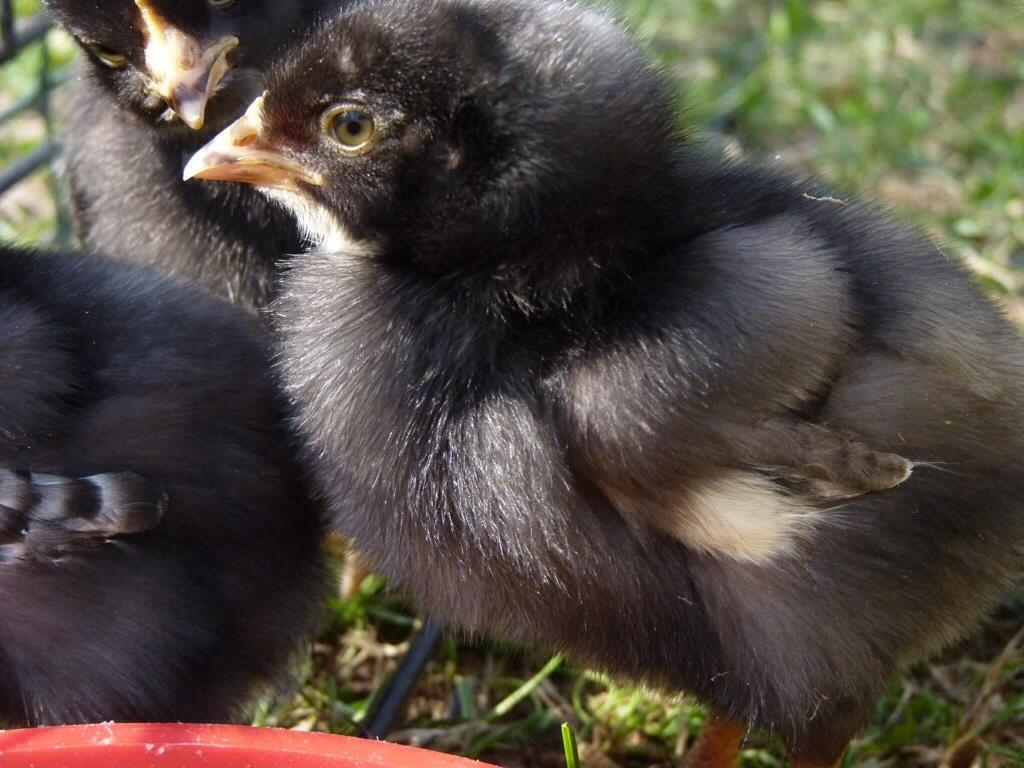What type of animals can be seen on the grass in the image? There are birds on the grass in the image. What is the purpose of the fence in the image? The purpose of the fence in the image is not explicitly stated, but it may be used to enclose an area or provide a boundary. What type of honey is being collected by the birds in the image? There is no honey present in the image, as it features birds on the grass and a fence. 